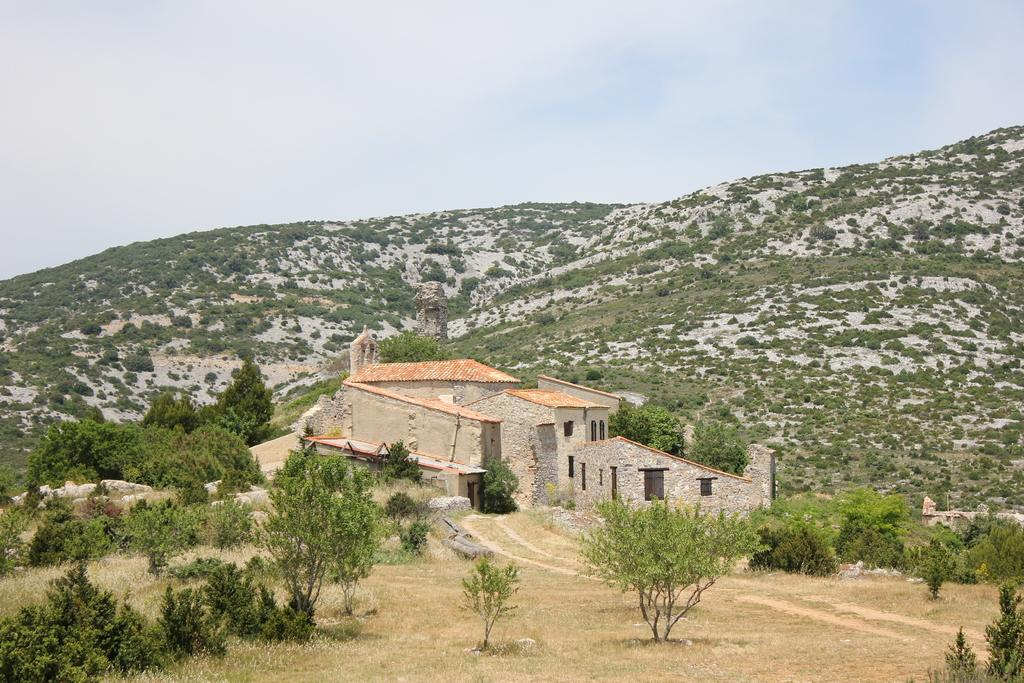What is the main structure in the middle of the image? There is a building in the middle of the image. What type of natural environment surrounds the building? There are many trees around the place. What can be seen in the distance behind the building? There are hills visible in the background of the image. How would you describe the weather based on the image? The sky is clear in the image, suggesting good weather. Where is the honey stored in the image? There is no honey present in the image. How many cows are visible in the image? There are no cows visible in the image. 